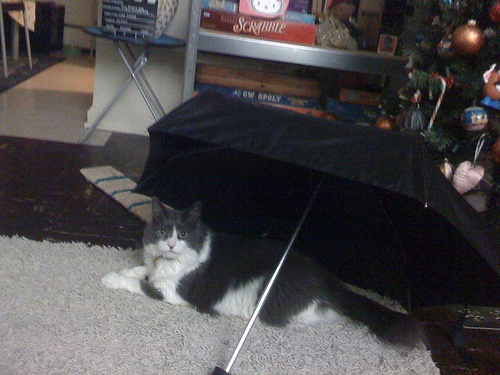Describe the objects in this image and their specific colors. I can see umbrella in gray, black, and maroon tones and cat in gray, black, darkgray, and lightgray tones in this image. 